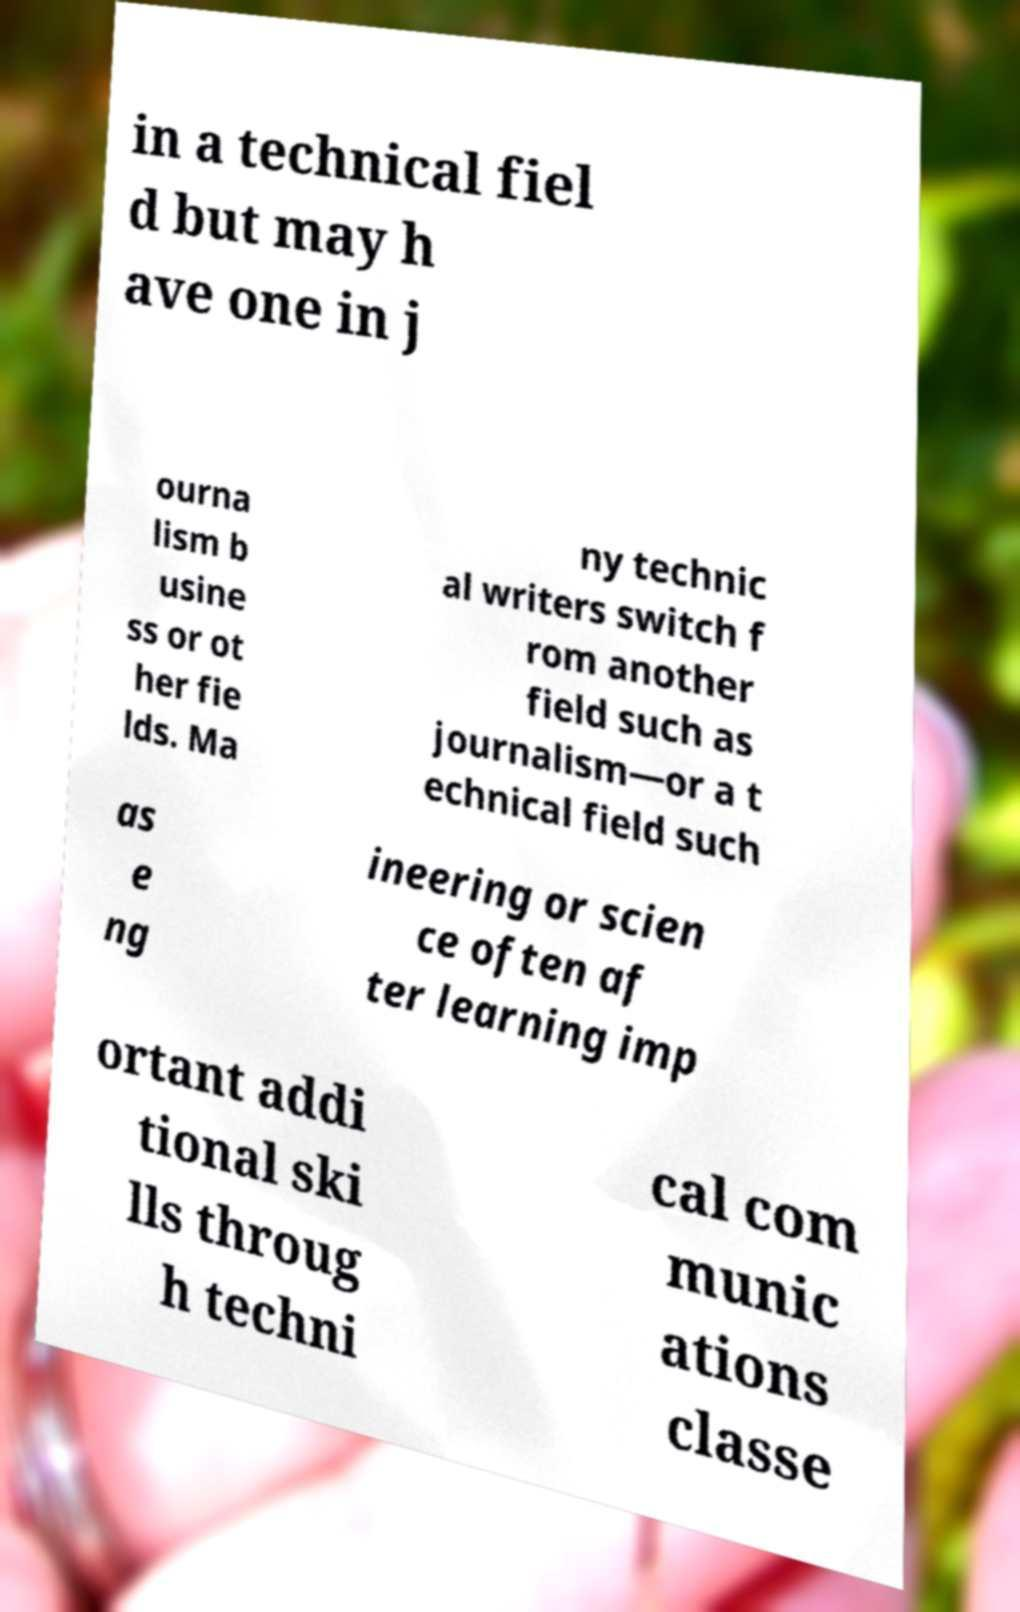I need the written content from this picture converted into text. Can you do that? in a technical fiel d but may h ave one in j ourna lism b usine ss or ot her fie lds. Ma ny technic al writers switch f rom another field such as journalism—or a t echnical field such as e ng ineering or scien ce often af ter learning imp ortant addi tional ski lls throug h techni cal com munic ations classe 